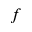Convert formula to latex. <formula><loc_0><loc_0><loc_500><loc_500>f</formula> 